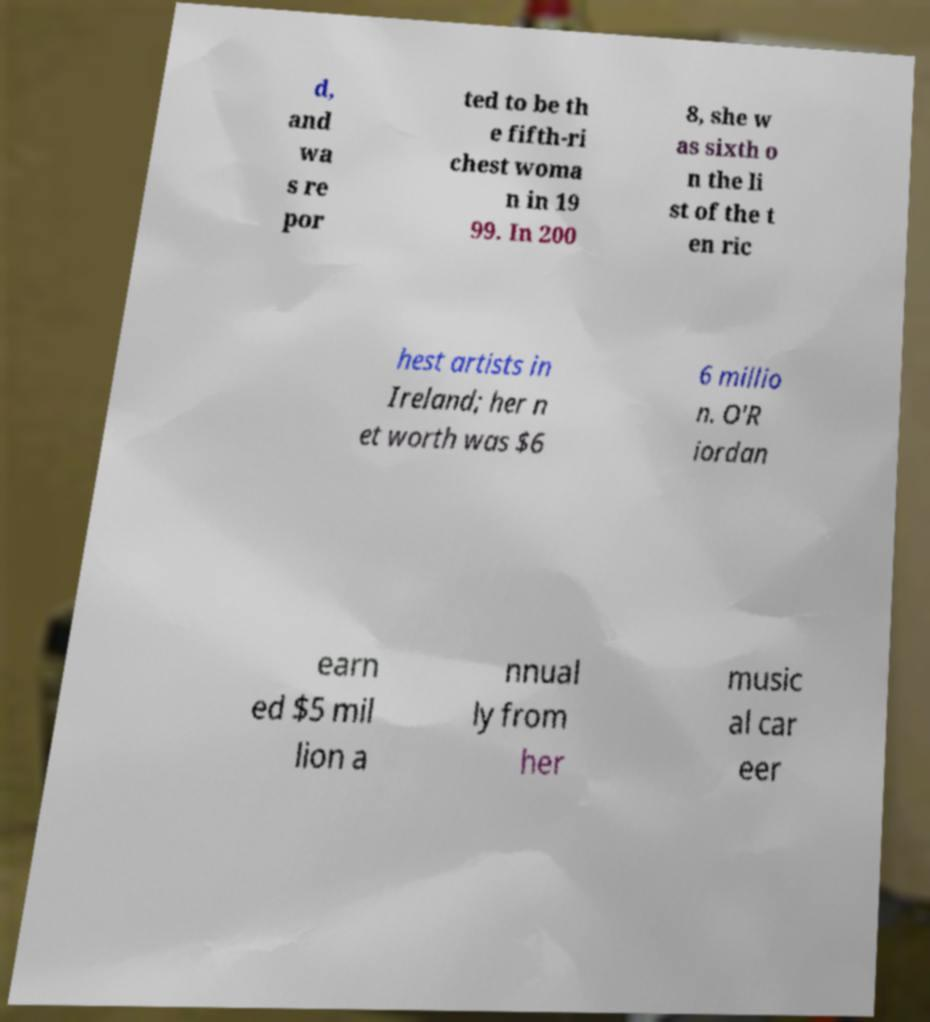Please read and relay the text visible in this image. What does it say? d, and wa s re por ted to be th e fifth-ri chest woma n in 19 99. In 200 8, she w as sixth o n the li st of the t en ric hest artists in Ireland; her n et worth was $6 6 millio n. O'R iordan earn ed $5 mil lion a nnual ly from her music al car eer 